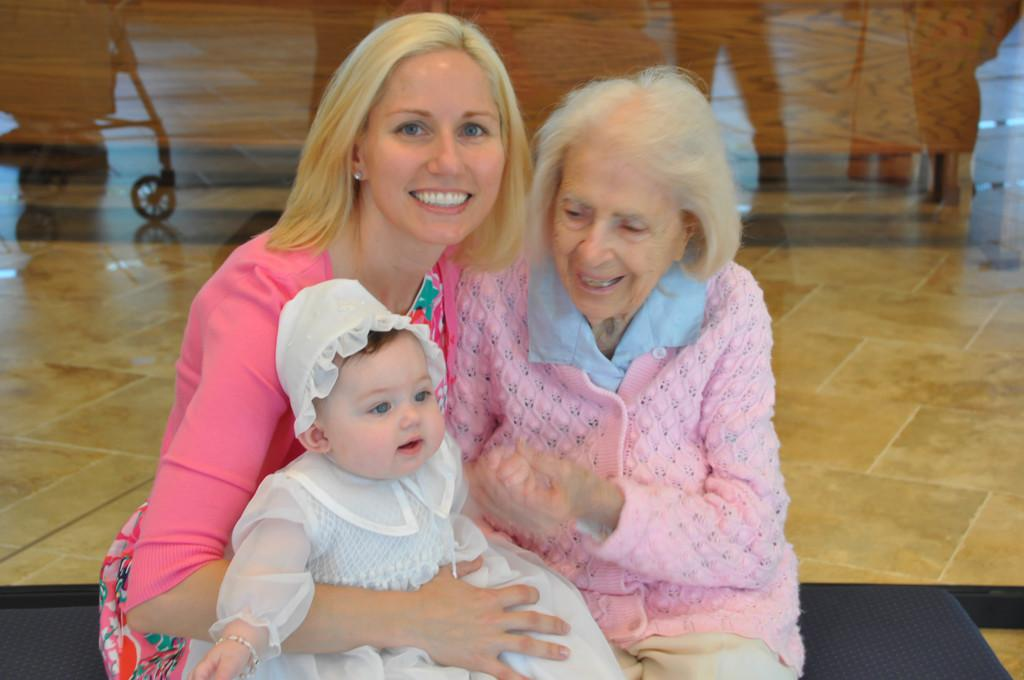Who or what is present in the image? There are people in the image. What are the people doing in the image? The people are sitting. How do the people appear to be feeling in the image? The people are smiling. What type of boundary can be seen in the image? There is no boundary present in the image; it features people sitting and smiling. 